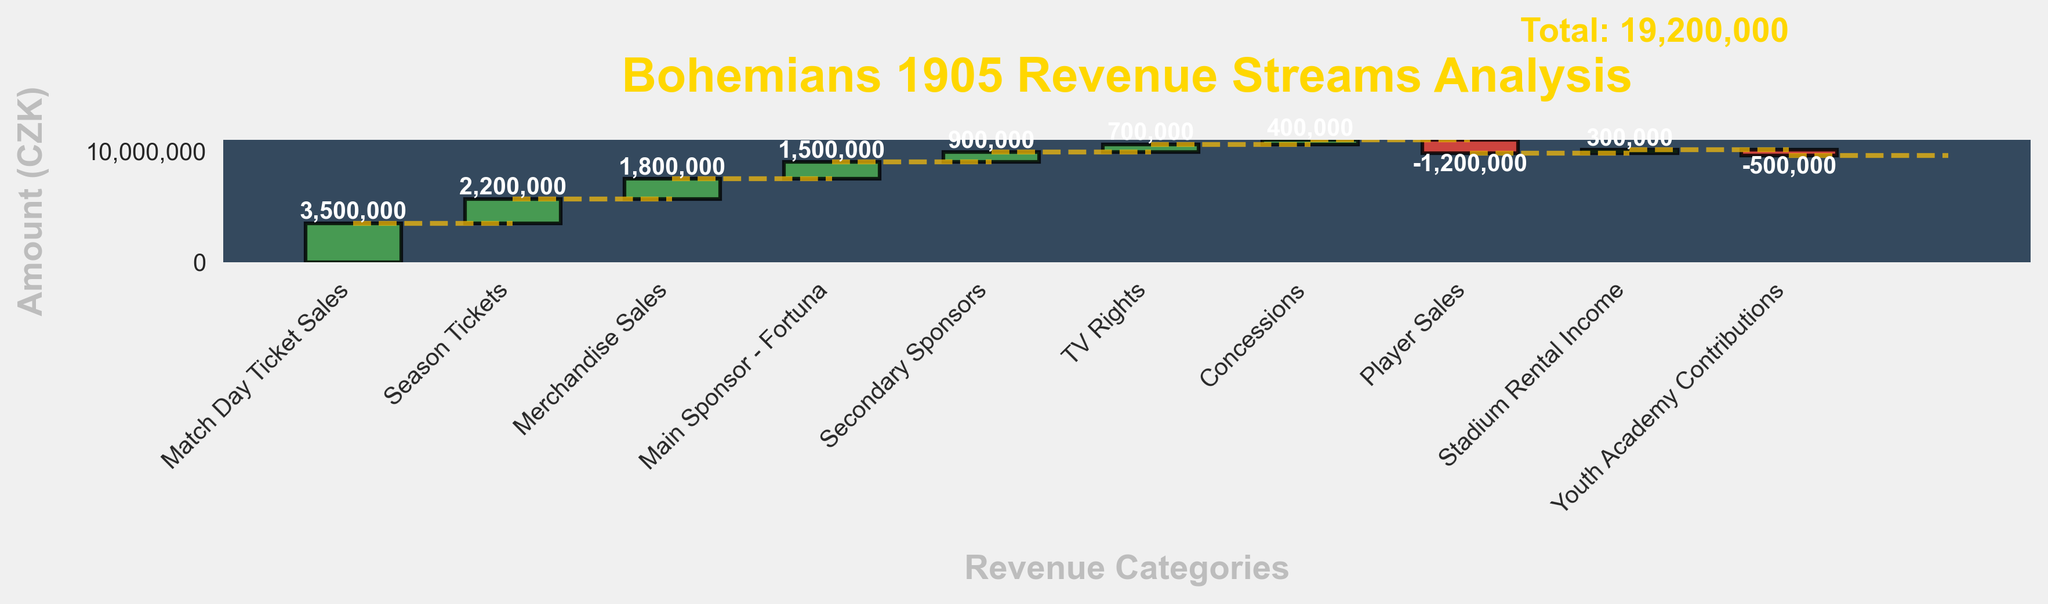What's the total revenue for Bohemians 1905? The total revenue is explicitly stated in the last bar of the waterfall chart labeled "Total Revenue."
Answer: 9,600,000 CZK Which category contributes the most positive revenue? By looking at the heights of the individual bars, "Match Day Ticket Sales" appears to contribute the largest positive amount.
Answer: Match Day Ticket Sales What is the total contribution from sponsorships including the main and secondary sponsors? Sum the amounts from "Main Sponsor - Fortuna" and "Secondary Sponsors." 1,500,000 CZK + 900,000 CZK = 2,400,000 CZK.
Answer: 2,400,000 CZK How much revenue did Bohemians 1905 lose from player sales? The "Player Sales" bar indicates the amount with a negative value, which is -1,200,000 CZK.
Answer: 1,200,000 CZK What’s the difference between the contributions from merchandise sales and TV rights? Subtract the amount from "TV Rights" from the amount from "Merchandise Sales." 1,800,000 CZK - 700,000 CZK = 1,100,000 CZK
Answer: 1,100,000 CZK What is the net impact of reductions from player sales and youth academy contributions? Sum up the negative amounts from "Player Sales" and "Youth Academy Contributions." -1,200,000 CZK + -500,000 CZK = -1,700,000 CZK.
Answer: -1,700,000 CZK Which category has the smallest positive contribution? The smallest positive bar belongs to "Concessions" with a value of 400,000 CZK.
Answer: Concessions What is the combined revenue from season tickets and concessions? Sum the amounts from "Season Tickets" and "Concessions." 2,200,000 CZK + 400,000 CZK = 2,600,000 CZK.
Answer: 2,600,000 CZK Which category has a higher revenue, stadium rental income or TV rights? Compare the amounts, 300,000 CZK (Stadium Rental Income) vs 700,000 CZK (TV Rights); TV Rights is higher.
Answer: TV Rights What is the average revenue of the positive contributions excluding the starting revenue and total revenue? Sum all positive contributions and divide by their count: (3,500,000 + 2,200,000 + 1,800,000 + 1,500,000 + 900,000 + 700,000 + 400,000 + 300,000) / 8 = 11,300,000 / 8 = 1,412,500 CZK.
Answer: 1,412,500 CZK 